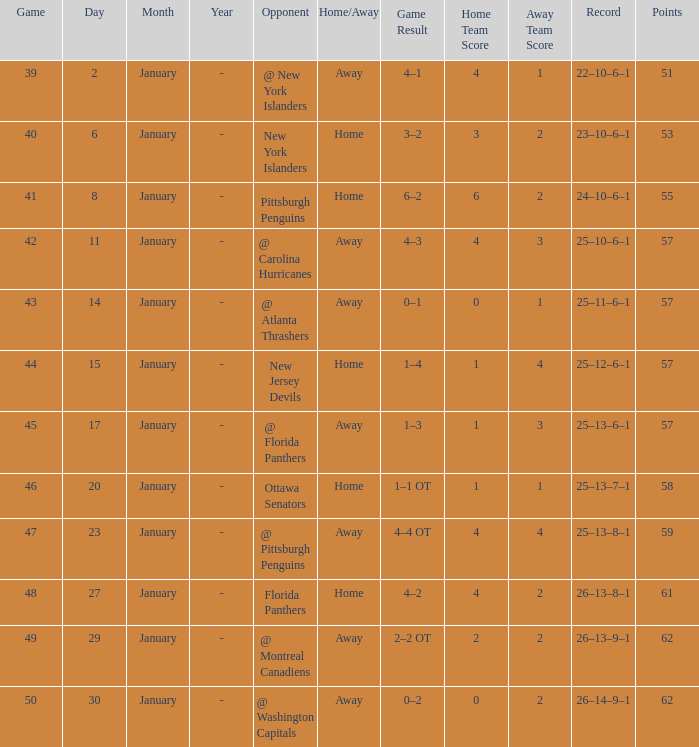What is the average for january with points of 51 2.0. 